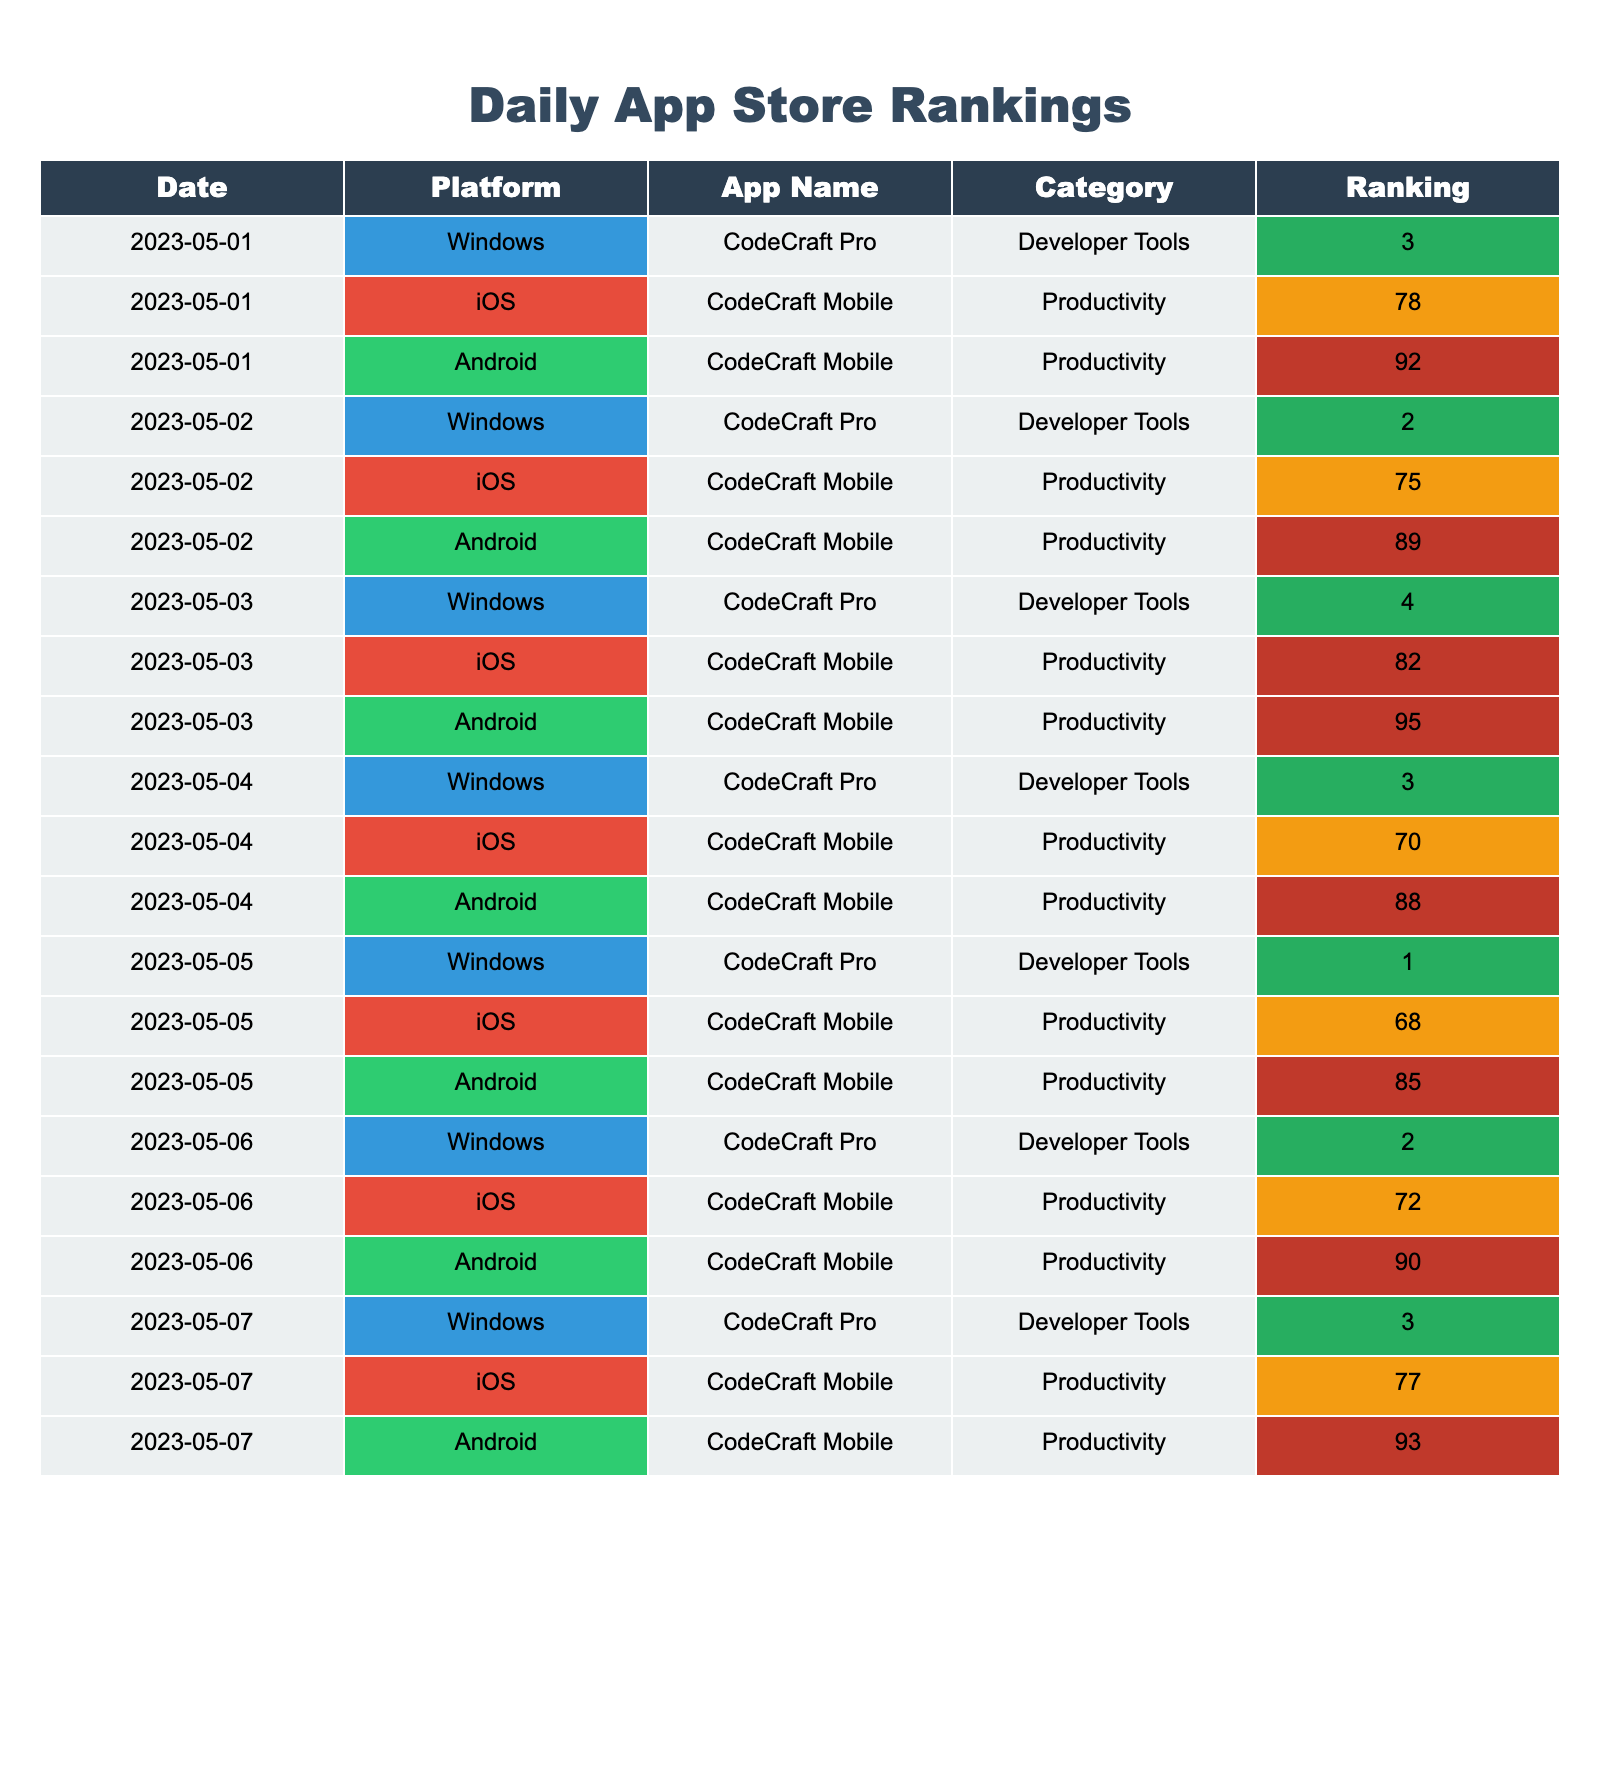What was the highest ranking of CodeCraft Pro on Windows? The table shows the rankings for CodeCraft Pro on Windows from May 1 to May 7. The highest ranking is 1, which occurred on May 5.
Answer: 1 What platform had the lowest ranking for CodeCraft Mobile on May 1? On May 1, the rankings for CodeCraft Mobile are 78 for iOS and 92 for Android. Android had the lowest ranking of 92.
Answer: Android What was the change in ranking for CodeCraft Pro on Windows from May 2 to May 3? On May 2, CodeCraft Pro was ranked 2, and on May 3, it was ranked 4. The change in ranking is 4 - 2 = 2, which means it dropped by 2 places.
Answer: Dropped by 2 places Which app consistently maintained a ranking below 80 on iOS? The table shows the rankings for CodeCraft Mobile on iOS from May 1 to May 7, with rankings always above 60. Thus, no app consistently maintained a ranking below 80.
Answer: No app What was the average ranking of CodeCraft Mobile on Android over the provided dates? The Android rankings for CodeCraft Mobile are 92, 89, 95, 88, 85, 90, and 93. Adding these gives 92 + 89 + 95 + 88 + 85 + 90 + 93 = 622. There are 7 days of data, so the average is 622 / 7, which equals approximately 88.86.
Answer: Approximately 88.86 On which day did CodeCraft Pro rank the lowest in its category? According to the table, CodeCraft Pro had its lowest ranking of 4 on May 3 and May 7. Therefore, both days are correct; however, May 3 is when it first appeared at that rank.
Answer: May 3 Did CodeCraft Mobile ever reach a ranking of 70 or higher on iOS? The iOS rankings for CodeCraft Mobile are 78, 75, 82, 70, 68, 72, and 77. All rankings but one (68) are 70 or higher, meaning yes, it did reach that ranking.
Answer: Yes What is the difference between the best and the worst ranking of CodeCraft Mobile on iOS? The best ranking for CodeCraft Mobile on iOS is 68 (on May 5) and the worst is 82 (on May 3). Therefore, the difference is 82 - 68 = 14.
Answer: 14 Which platform had the most fluctuations in rankings for CodeCraft Mobile based on the given data? By analyzing the iOS and Android rankings over the 7 days, the Android rankings fluctuated from 92 to 85 (a total of 7 position changes), while iOS fluctuated from 78 to 68 (a total of 10 position changes). Therefore, Android had fewer overall fluctuations.
Answer: iOS What was the total number of days CodeCraft Pro achieved a ranking of 2? The table indicates that CodeCraft Pro achieved a ranking of 2 on two separate days: May 2 and May 6. Therefore, the total is 2 days.
Answer: 2 days 